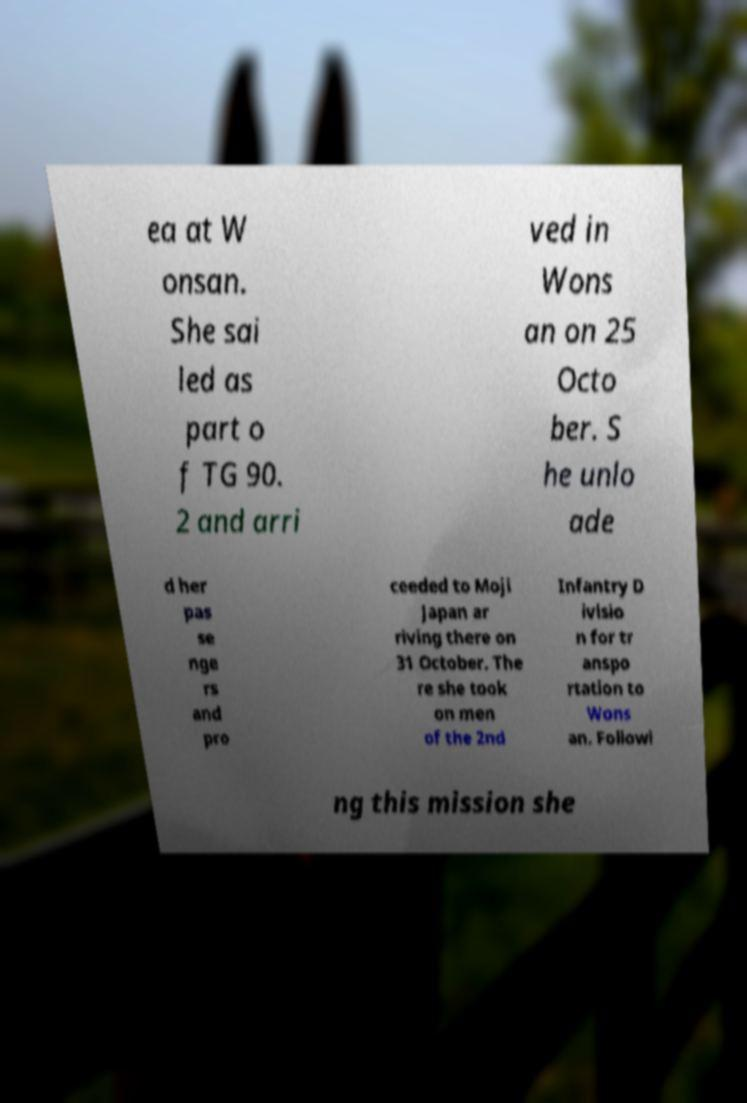What messages or text are displayed in this image? I need them in a readable, typed format. ea at W onsan. She sai led as part o f TG 90. 2 and arri ved in Wons an on 25 Octo ber. S he unlo ade d her pas se nge rs and pro ceeded to Moji Japan ar riving there on 31 October. The re she took on men of the 2nd Infantry D ivisio n for tr anspo rtation to Wons an. Followi ng this mission she 